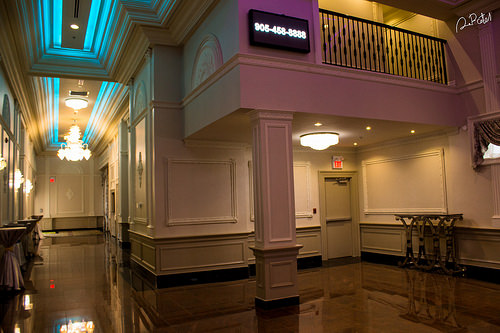<image>
Is there a tv above the pillar? Yes. The tv is positioned above the pillar in the vertical space, higher up in the scene. 